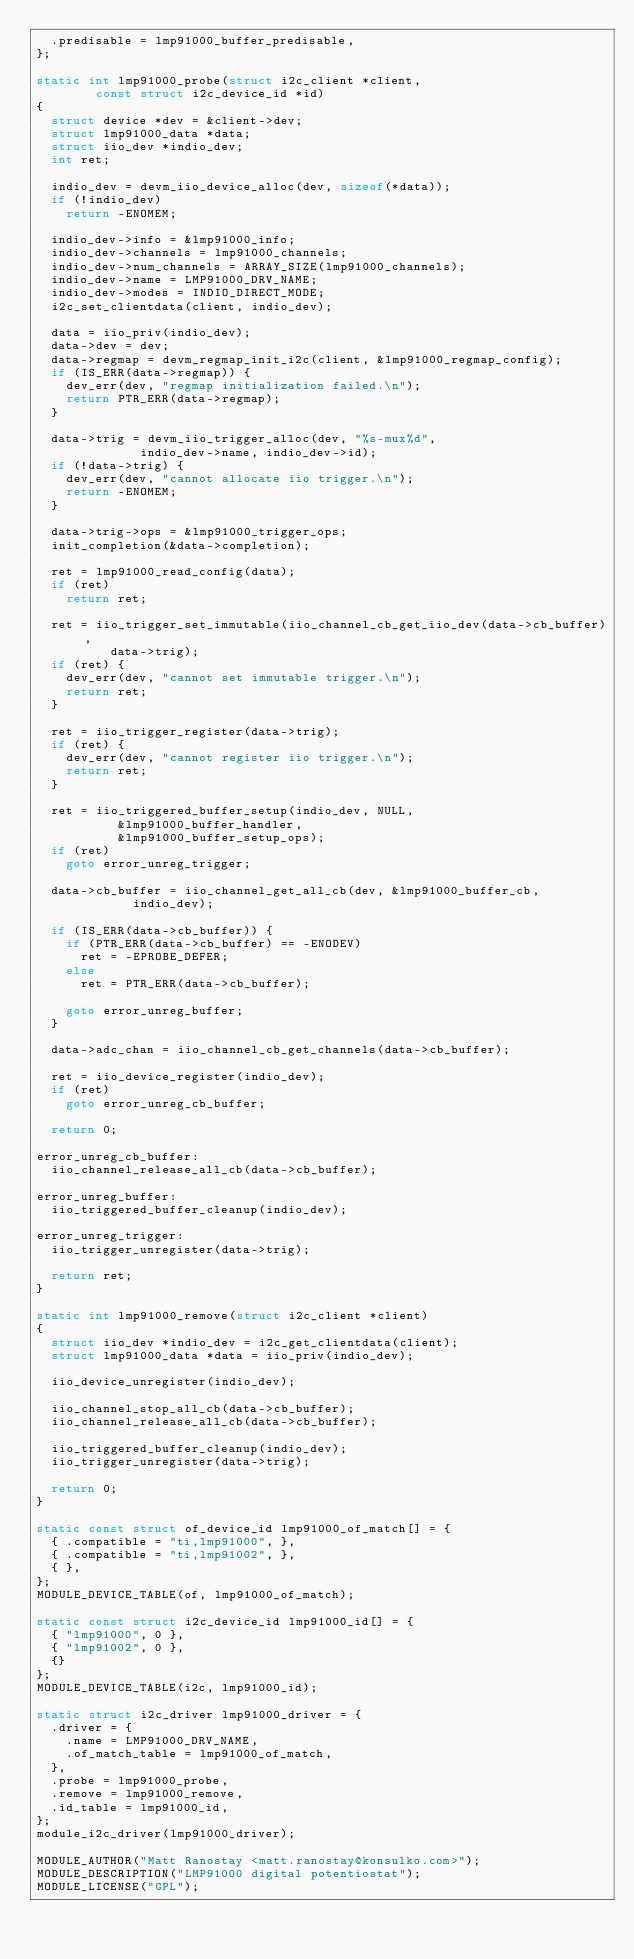Convert code to text. <code><loc_0><loc_0><loc_500><loc_500><_C_>	.predisable = lmp91000_buffer_predisable,
};

static int lmp91000_probe(struct i2c_client *client,
			  const struct i2c_device_id *id)
{
	struct device *dev = &client->dev;
	struct lmp91000_data *data;
	struct iio_dev *indio_dev;
	int ret;

	indio_dev = devm_iio_device_alloc(dev, sizeof(*data));
	if (!indio_dev)
		return -ENOMEM;

	indio_dev->info = &lmp91000_info;
	indio_dev->channels = lmp91000_channels;
	indio_dev->num_channels = ARRAY_SIZE(lmp91000_channels);
	indio_dev->name = LMP91000_DRV_NAME;
	indio_dev->modes = INDIO_DIRECT_MODE;
	i2c_set_clientdata(client, indio_dev);

	data = iio_priv(indio_dev);
	data->dev = dev;
	data->regmap = devm_regmap_init_i2c(client, &lmp91000_regmap_config);
	if (IS_ERR(data->regmap)) {
		dev_err(dev, "regmap initialization failed.\n");
		return PTR_ERR(data->regmap);
	}

	data->trig = devm_iio_trigger_alloc(dev, "%s-mux%d",
					    indio_dev->name, indio_dev->id);
	if (!data->trig) {
		dev_err(dev, "cannot allocate iio trigger.\n");
		return -ENOMEM;
	}

	data->trig->ops = &lmp91000_trigger_ops;
	init_completion(&data->completion);

	ret = lmp91000_read_config(data);
	if (ret)
		return ret;

	ret = iio_trigger_set_immutable(iio_channel_cb_get_iio_dev(data->cb_buffer),
					data->trig);
	if (ret) {
		dev_err(dev, "cannot set immutable trigger.\n");
		return ret;
	}

	ret = iio_trigger_register(data->trig);
	if (ret) {
		dev_err(dev, "cannot register iio trigger.\n");
		return ret;
	}

	ret = iio_triggered_buffer_setup(indio_dev, NULL,
					 &lmp91000_buffer_handler,
					 &lmp91000_buffer_setup_ops);
	if (ret)
		goto error_unreg_trigger;

	data->cb_buffer = iio_channel_get_all_cb(dev, &lmp91000_buffer_cb,
						 indio_dev);

	if (IS_ERR(data->cb_buffer)) {
		if (PTR_ERR(data->cb_buffer) == -ENODEV)
			ret = -EPROBE_DEFER;
		else
			ret = PTR_ERR(data->cb_buffer);

		goto error_unreg_buffer;
	}

	data->adc_chan = iio_channel_cb_get_channels(data->cb_buffer);

	ret = iio_device_register(indio_dev);
	if (ret)
		goto error_unreg_cb_buffer;

	return 0;

error_unreg_cb_buffer:
	iio_channel_release_all_cb(data->cb_buffer);

error_unreg_buffer:
	iio_triggered_buffer_cleanup(indio_dev);

error_unreg_trigger:
	iio_trigger_unregister(data->trig);

	return ret;
}

static int lmp91000_remove(struct i2c_client *client)
{
	struct iio_dev *indio_dev = i2c_get_clientdata(client);
	struct lmp91000_data *data = iio_priv(indio_dev);

	iio_device_unregister(indio_dev);

	iio_channel_stop_all_cb(data->cb_buffer);
	iio_channel_release_all_cb(data->cb_buffer);

	iio_triggered_buffer_cleanup(indio_dev);
	iio_trigger_unregister(data->trig);

	return 0;
}

static const struct of_device_id lmp91000_of_match[] = {
	{ .compatible = "ti,lmp91000", },
	{ .compatible = "ti,lmp91002", },
	{ },
};
MODULE_DEVICE_TABLE(of, lmp91000_of_match);

static const struct i2c_device_id lmp91000_id[] = {
	{ "lmp91000", 0 },
	{ "lmp91002", 0 },
	{}
};
MODULE_DEVICE_TABLE(i2c, lmp91000_id);

static struct i2c_driver lmp91000_driver = {
	.driver = {
		.name = LMP91000_DRV_NAME,
		.of_match_table = lmp91000_of_match,
	},
	.probe = lmp91000_probe,
	.remove = lmp91000_remove,
	.id_table = lmp91000_id,
};
module_i2c_driver(lmp91000_driver);

MODULE_AUTHOR("Matt Ranostay <matt.ranostay@konsulko.com>");
MODULE_DESCRIPTION("LMP91000 digital potentiostat");
MODULE_LICENSE("GPL");
</code> 